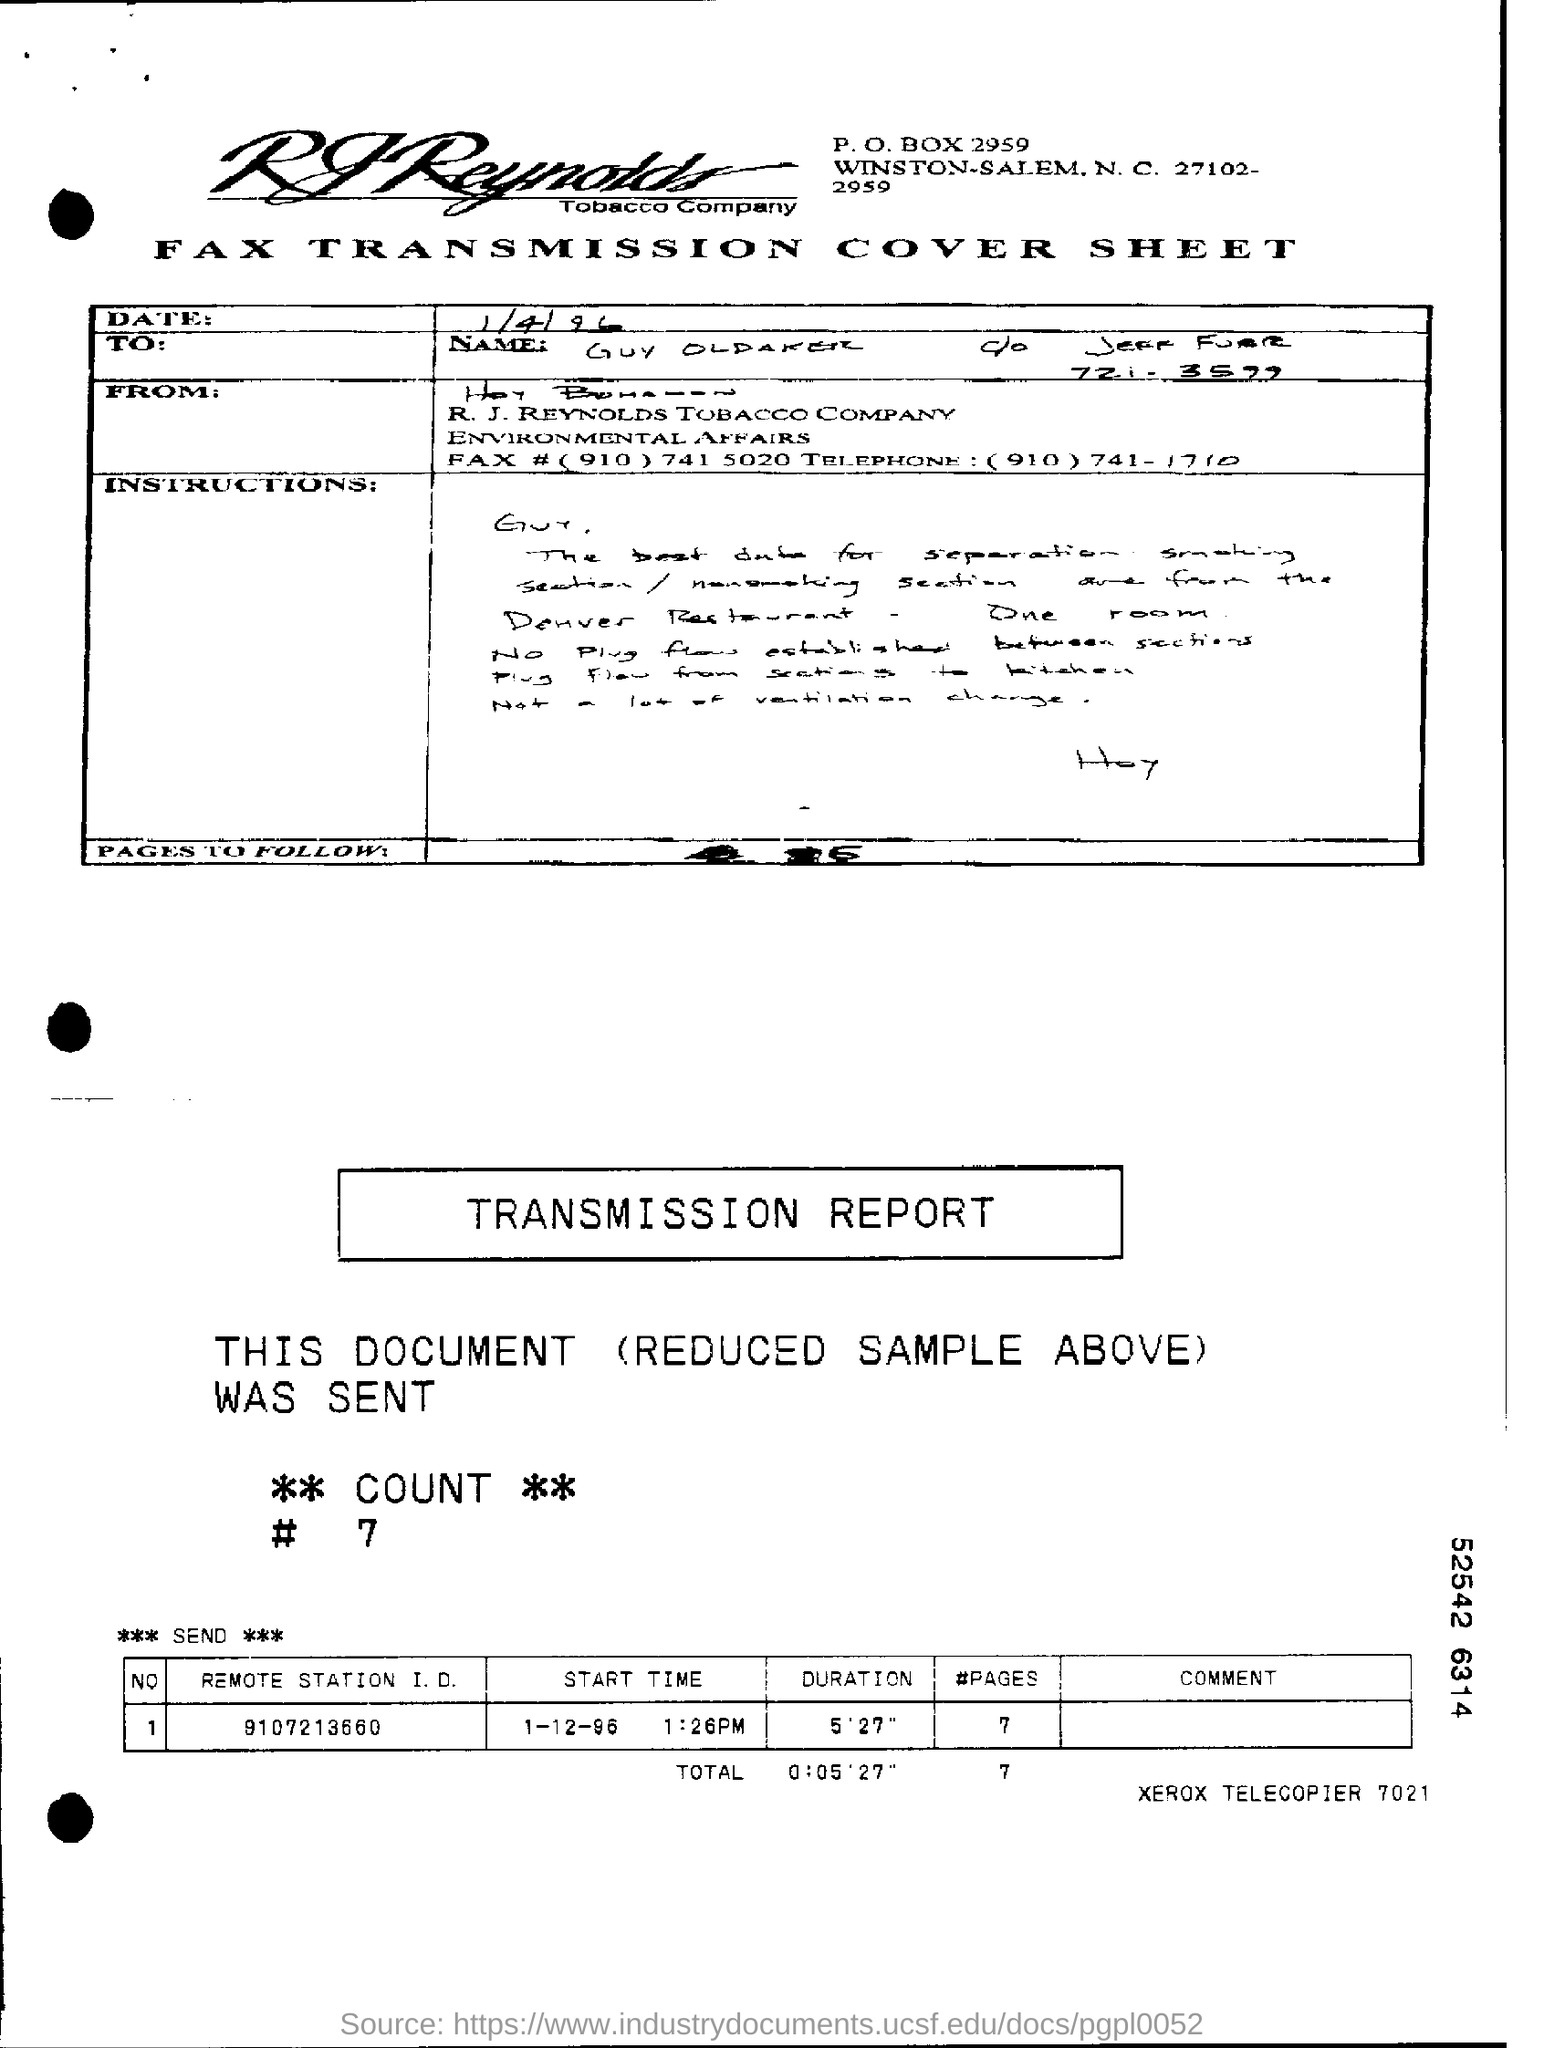Outline some significant characteristics in this image. The PO Box number of the company is 2959. The transmission was made on December 1st, 1996. The remote station identification number is 9107213660. 